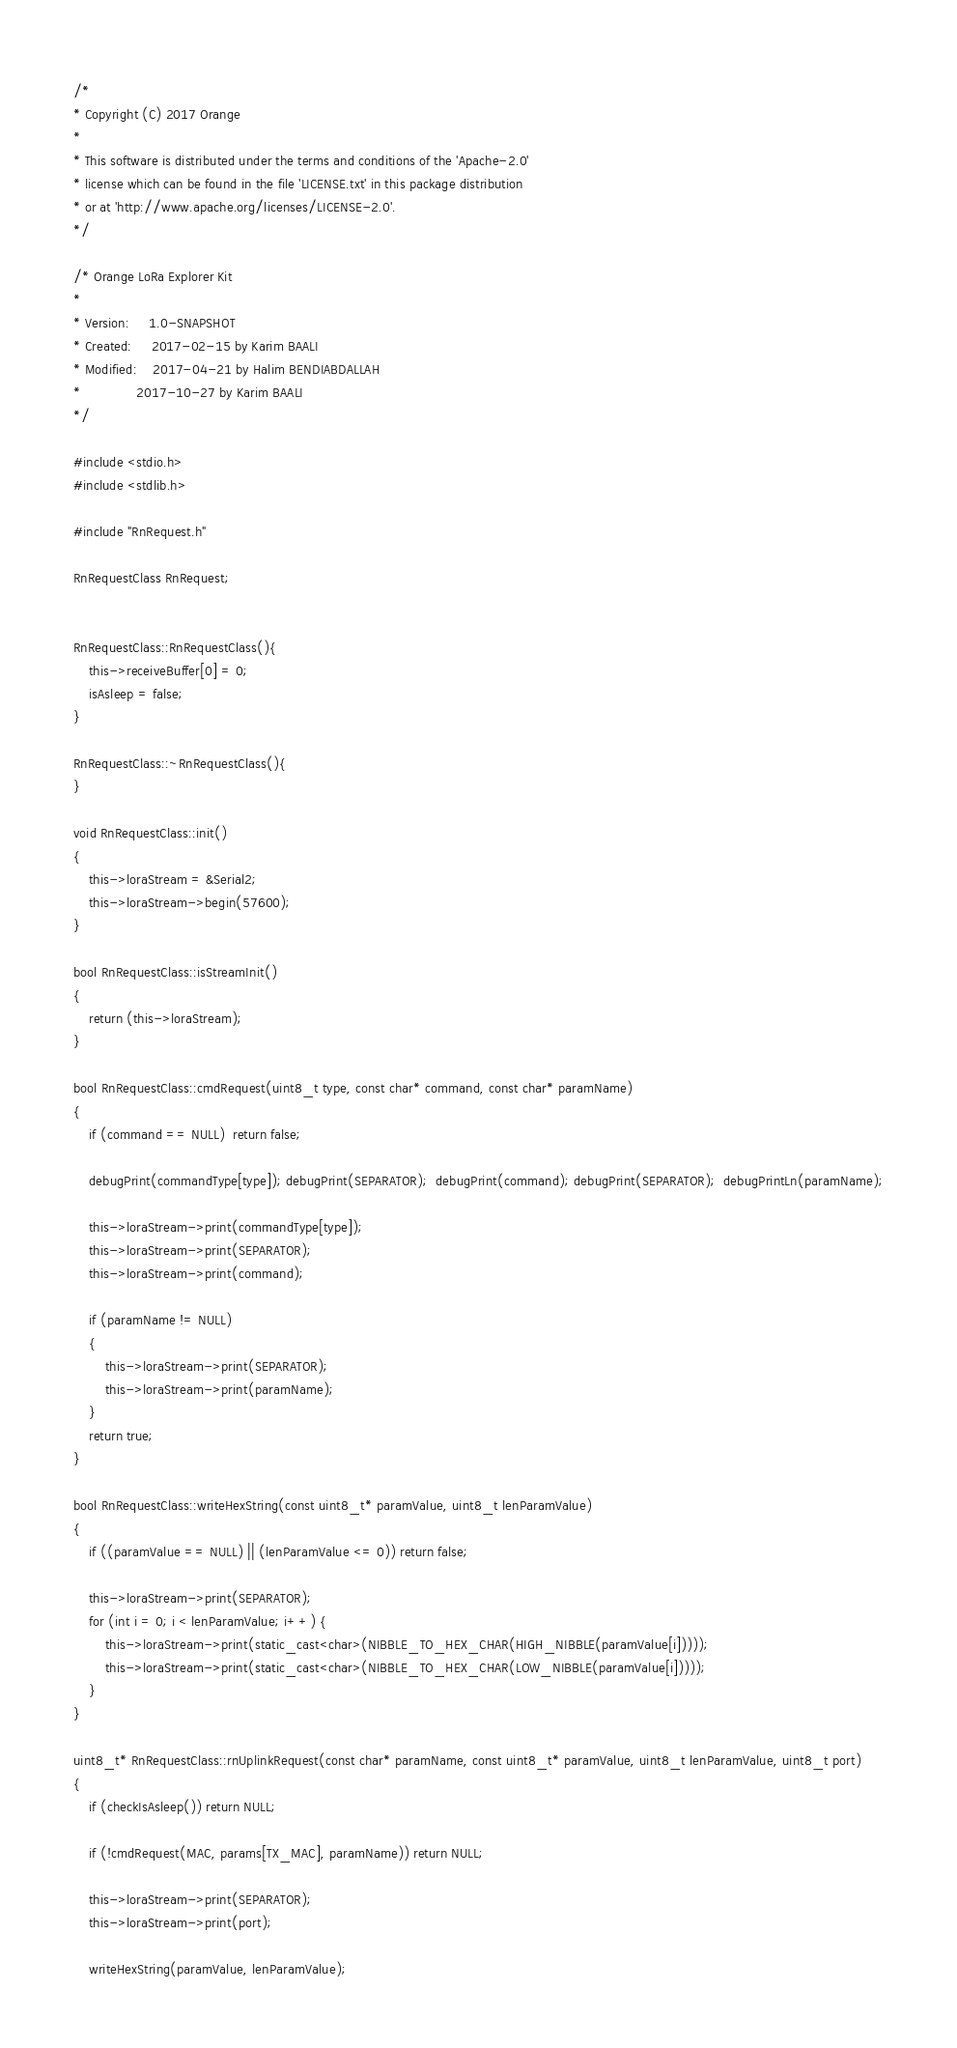Convert code to text. <code><loc_0><loc_0><loc_500><loc_500><_C++_>/*
* Copyright (C) 2017 Orange
*
* This software is distributed under the terms and conditions of the 'Apache-2.0'
* license which can be found in the file 'LICENSE.txt' in this package distribution
* or at 'http://www.apache.org/licenses/LICENSE-2.0'.
*/

/* Orange LoRa Explorer Kit
*
* Version:     1.0-SNAPSHOT
* Created:     2017-02-15 by Karim BAALI
* Modified:    2017-04-21 by Halim BENDIABDALLAH
*			   2017-10-27 by Karim BAALI
*/

#include <stdio.h>
#include <stdlib.h>

#include "RnRequest.h"

RnRequestClass RnRequest;


RnRequestClass::RnRequestClass(){
	this->receiveBuffer[0] = 0;
	isAsleep = false;
}

RnRequestClass::~RnRequestClass(){
}

void RnRequestClass::init()
{
	this->loraStream = &Serial2;
	this->loraStream->begin(57600);
}

bool RnRequestClass::isStreamInit()
{
	return (this->loraStream);
}

bool RnRequestClass::cmdRequest(uint8_t type, const char* command, const char* paramName)
{
	if (command == NULL)  return false;

	debugPrint(commandType[type]); debugPrint(SEPARATOR);  debugPrint(command); debugPrint(SEPARATOR);  debugPrintLn(paramName);

	this->loraStream->print(commandType[type]);
	this->loraStream->print(SEPARATOR);
	this->loraStream->print(command);

	if (paramName != NULL)
	{
		this->loraStream->print(SEPARATOR);
		this->loraStream->print(paramName);
	}
	return true;
}

bool RnRequestClass::writeHexString(const uint8_t* paramValue, uint8_t lenParamValue)
{
	if ((paramValue == NULL) || (lenParamValue <= 0)) return false;

	this->loraStream->print(SEPARATOR);
	for (int i = 0; i < lenParamValue; i++) {
		this->loraStream->print(static_cast<char>(NIBBLE_TO_HEX_CHAR(HIGH_NIBBLE(paramValue[i]))));
		this->loraStream->print(static_cast<char>(NIBBLE_TO_HEX_CHAR(LOW_NIBBLE(paramValue[i]))));
	}
}

uint8_t* RnRequestClass::rnUplinkRequest(const char* paramName, const uint8_t* paramValue, uint8_t lenParamValue, uint8_t port)
{
	if (checkIsAsleep()) return NULL;

	if (!cmdRequest(MAC, params[TX_MAC], paramName)) return NULL;

	this->loraStream->print(SEPARATOR);
	this->loraStream->print(port);

	writeHexString(paramValue, lenParamValue);</code> 